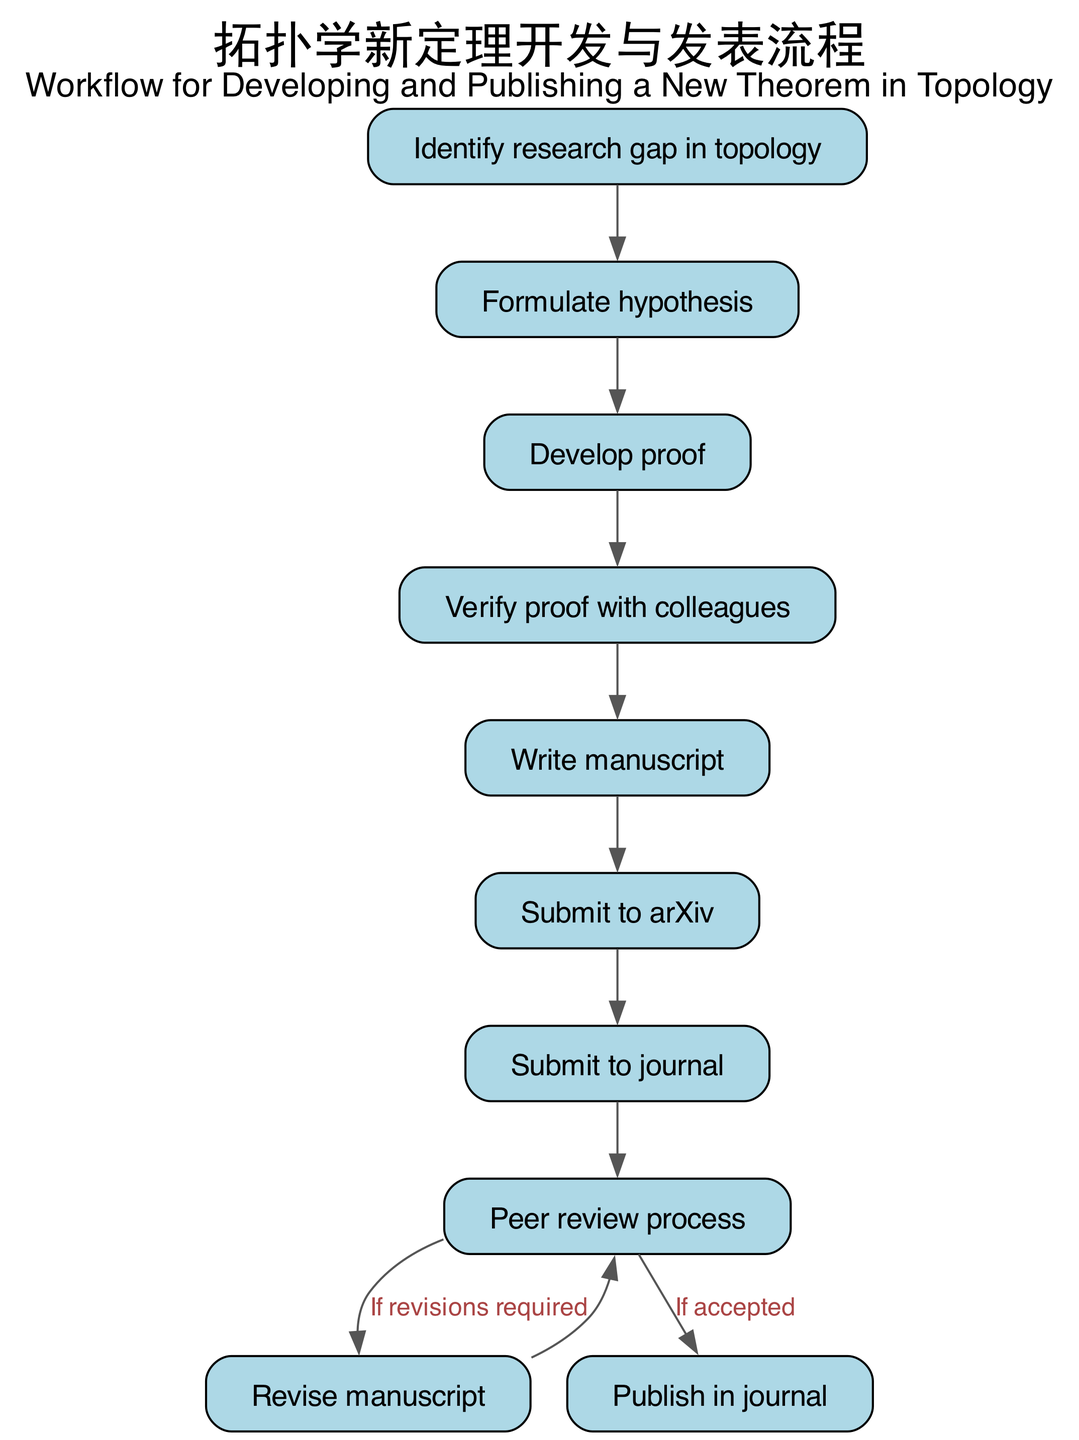What is the first step in the workflow? The diagram shows the first node, which is labeled "Identify research gap in topology." This indicates that the workflow begins with this step.
Answer: Identify research gap in topology How many nodes are there in total? We can count the number of individual nodes listed in the diagram. There are 10 nodes present in the workflow.
Answer: 10 What step follows the "Formulate hypothesis"? According to the flow, the edge leading from "Formulate hypothesis" points to the next step, which is labeled "Develop proof." This indicates the next action in the workflow.
Answer: Develop proof What happens after the "Peer review process" if revisions are required? The diagram indicates an edge leading back from "Peer review process" to "Revise manuscript" when revisions are required. This means that the process loops back to allow for necessary changes.
Answer: Revise manuscript What is the last step in the workflow? The final node in the diagram is labeled "Publish in journal." This indicates that the workflow concludes with this action once all earlier steps are completed.
Answer: Publish in journal Which step directly precedes the "Submit to journal"? The edge connection shows that "Submit to journal" is directly preceded by "Submit to arXiv." This indicates the order of operations in the workflow.
Answer: Submit to arXiv What condition leads to revising the manuscript? The diagram states that the "Peer review process" connects back to "Revise manuscript" with the condition "If revisions required." This specifies the situation in which the revision is necessary.
Answer: If revisions required How many edges are there in the diagram? By counting the connections between nodes, we can find that there are 9 edges linking the workflow steps together in the process.
Answer: 9 